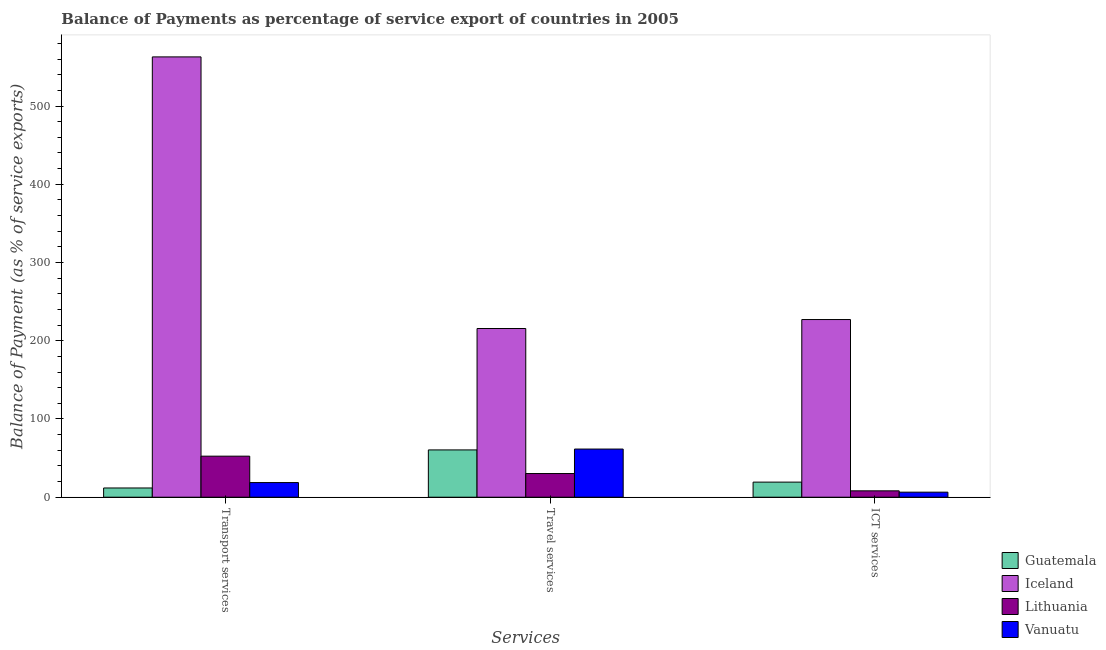How many different coloured bars are there?
Your answer should be compact. 4. How many groups of bars are there?
Provide a succinct answer. 3. Are the number of bars per tick equal to the number of legend labels?
Give a very brief answer. Yes. How many bars are there on the 3rd tick from the left?
Keep it short and to the point. 4. How many bars are there on the 1st tick from the right?
Give a very brief answer. 4. What is the label of the 1st group of bars from the left?
Offer a terse response. Transport services. What is the balance of payment of ict services in Guatemala?
Keep it short and to the point. 19.31. Across all countries, what is the maximum balance of payment of ict services?
Provide a short and direct response. 227.09. Across all countries, what is the minimum balance of payment of ict services?
Ensure brevity in your answer.  6.47. In which country was the balance of payment of transport services minimum?
Give a very brief answer. Guatemala. What is the total balance of payment of transport services in the graph?
Provide a succinct answer. 645.81. What is the difference between the balance of payment of transport services in Vanuatu and that in Guatemala?
Your answer should be compact. 6.9. What is the difference between the balance of payment of ict services in Iceland and the balance of payment of travel services in Guatemala?
Offer a terse response. 166.63. What is the average balance of payment of transport services per country?
Your response must be concise. 161.45. What is the difference between the balance of payment of transport services and balance of payment of ict services in Vanuatu?
Your answer should be compact. 12.25. In how many countries, is the balance of payment of ict services greater than 520 %?
Ensure brevity in your answer.  0. What is the ratio of the balance of payment of ict services in Guatemala to that in Lithuania?
Provide a short and direct response. 2.37. Is the balance of payment of travel services in Lithuania less than that in Guatemala?
Keep it short and to the point. Yes. What is the difference between the highest and the second highest balance of payment of ict services?
Offer a terse response. 207.78. What is the difference between the highest and the lowest balance of payment of travel services?
Provide a short and direct response. 185.37. Is the sum of the balance of payment of transport services in Iceland and Vanuatu greater than the maximum balance of payment of ict services across all countries?
Offer a very short reply. Yes. What does the 1st bar from the left in ICT services represents?
Provide a short and direct response. Guatemala. What does the 3rd bar from the right in Transport services represents?
Give a very brief answer. Iceland. Is it the case that in every country, the sum of the balance of payment of transport services and balance of payment of travel services is greater than the balance of payment of ict services?
Offer a terse response. Yes. Are all the bars in the graph horizontal?
Your response must be concise. No. How many countries are there in the graph?
Your response must be concise. 4. What is the difference between two consecutive major ticks on the Y-axis?
Your response must be concise. 100. How many legend labels are there?
Offer a very short reply. 4. What is the title of the graph?
Ensure brevity in your answer.  Balance of Payments as percentage of service export of countries in 2005. What is the label or title of the X-axis?
Give a very brief answer. Services. What is the label or title of the Y-axis?
Provide a short and direct response. Balance of Payment (as % of service exports). What is the Balance of Payment (as % of service exports) in Guatemala in Transport services?
Provide a succinct answer. 11.81. What is the Balance of Payment (as % of service exports) of Iceland in Transport services?
Make the answer very short. 562.81. What is the Balance of Payment (as % of service exports) of Lithuania in Transport services?
Keep it short and to the point. 52.47. What is the Balance of Payment (as % of service exports) of Vanuatu in Transport services?
Your answer should be compact. 18.72. What is the Balance of Payment (as % of service exports) in Guatemala in Travel services?
Your answer should be very brief. 60.46. What is the Balance of Payment (as % of service exports) of Iceland in Travel services?
Give a very brief answer. 215.64. What is the Balance of Payment (as % of service exports) in Lithuania in Travel services?
Offer a terse response. 30.28. What is the Balance of Payment (as % of service exports) of Vanuatu in Travel services?
Make the answer very short. 61.55. What is the Balance of Payment (as % of service exports) of Guatemala in ICT services?
Provide a succinct answer. 19.31. What is the Balance of Payment (as % of service exports) of Iceland in ICT services?
Give a very brief answer. 227.09. What is the Balance of Payment (as % of service exports) in Lithuania in ICT services?
Give a very brief answer. 8.16. What is the Balance of Payment (as % of service exports) in Vanuatu in ICT services?
Ensure brevity in your answer.  6.47. Across all Services, what is the maximum Balance of Payment (as % of service exports) of Guatemala?
Ensure brevity in your answer.  60.46. Across all Services, what is the maximum Balance of Payment (as % of service exports) in Iceland?
Give a very brief answer. 562.81. Across all Services, what is the maximum Balance of Payment (as % of service exports) of Lithuania?
Provide a succinct answer. 52.47. Across all Services, what is the maximum Balance of Payment (as % of service exports) in Vanuatu?
Ensure brevity in your answer.  61.55. Across all Services, what is the minimum Balance of Payment (as % of service exports) in Guatemala?
Provide a short and direct response. 11.81. Across all Services, what is the minimum Balance of Payment (as % of service exports) in Iceland?
Offer a very short reply. 215.64. Across all Services, what is the minimum Balance of Payment (as % of service exports) of Lithuania?
Your answer should be compact. 8.16. Across all Services, what is the minimum Balance of Payment (as % of service exports) of Vanuatu?
Keep it short and to the point. 6.47. What is the total Balance of Payment (as % of service exports) of Guatemala in the graph?
Provide a short and direct response. 91.58. What is the total Balance of Payment (as % of service exports) of Iceland in the graph?
Ensure brevity in your answer.  1005.54. What is the total Balance of Payment (as % of service exports) in Lithuania in the graph?
Offer a terse response. 90.9. What is the total Balance of Payment (as % of service exports) of Vanuatu in the graph?
Keep it short and to the point. 86.74. What is the difference between the Balance of Payment (as % of service exports) in Guatemala in Transport services and that in Travel services?
Ensure brevity in your answer.  -48.65. What is the difference between the Balance of Payment (as % of service exports) of Iceland in Transport services and that in Travel services?
Your answer should be very brief. 347.16. What is the difference between the Balance of Payment (as % of service exports) in Lithuania in Transport services and that in Travel services?
Offer a very short reply. 22.2. What is the difference between the Balance of Payment (as % of service exports) in Vanuatu in Transport services and that in Travel services?
Keep it short and to the point. -42.84. What is the difference between the Balance of Payment (as % of service exports) of Guatemala in Transport services and that in ICT services?
Provide a short and direct response. -7.49. What is the difference between the Balance of Payment (as % of service exports) of Iceland in Transport services and that in ICT services?
Give a very brief answer. 335.71. What is the difference between the Balance of Payment (as % of service exports) of Lithuania in Transport services and that in ICT services?
Provide a succinct answer. 44.32. What is the difference between the Balance of Payment (as % of service exports) of Vanuatu in Transport services and that in ICT services?
Make the answer very short. 12.25. What is the difference between the Balance of Payment (as % of service exports) in Guatemala in Travel services and that in ICT services?
Your answer should be compact. 41.15. What is the difference between the Balance of Payment (as % of service exports) of Iceland in Travel services and that in ICT services?
Make the answer very short. -11.45. What is the difference between the Balance of Payment (as % of service exports) of Lithuania in Travel services and that in ICT services?
Offer a very short reply. 22.12. What is the difference between the Balance of Payment (as % of service exports) of Vanuatu in Travel services and that in ICT services?
Your response must be concise. 55.09. What is the difference between the Balance of Payment (as % of service exports) in Guatemala in Transport services and the Balance of Payment (as % of service exports) in Iceland in Travel services?
Keep it short and to the point. -203.83. What is the difference between the Balance of Payment (as % of service exports) of Guatemala in Transport services and the Balance of Payment (as % of service exports) of Lithuania in Travel services?
Your answer should be very brief. -18.46. What is the difference between the Balance of Payment (as % of service exports) of Guatemala in Transport services and the Balance of Payment (as % of service exports) of Vanuatu in Travel services?
Your answer should be very brief. -49.74. What is the difference between the Balance of Payment (as % of service exports) of Iceland in Transport services and the Balance of Payment (as % of service exports) of Lithuania in Travel services?
Give a very brief answer. 532.53. What is the difference between the Balance of Payment (as % of service exports) in Iceland in Transport services and the Balance of Payment (as % of service exports) in Vanuatu in Travel services?
Your answer should be compact. 501.25. What is the difference between the Balance of Payment (as % of service exports) in Lithuania in Transport services and the Balance of Payment (as % of service exports) in Vanuatu in Travel services?
Offer a terse response. -9.08. What is the difference between the Balance of Payment (as % of service exports) of Guatemala in Transport services and the Balance of Payment (as % of service exports) of Iceland in ICT services?
Offer a very short reply. -215.28. What is the difference between the Balance of Payment (as % of service exports) in Guatemala in Transport services and the Balance of Payment (as % of service exports) in Lithuania in ICT services?
Offer a terse response. 3.66. What is the difference between the Balance of Payment (as % of service exports) of Guatemala in Transport services and the Balance of Payment (as % of service exports) of Vanuatu in ICT services?
Make the answer very short. 5.35. What is the difference between the Balance of Payment (as % of service exports) in Iceland in Transport services and the Balance of Payment (as % of service exports) in Lithuania in ICT services?
Your response must be concise. 554.65. What is the difference between the Balance of Payment (as % of service exports) in Iceland in Transport services and the Balance of Payment (as % of service exports) in Vanuatu in ICT services?
Your response must be concise. 556.34. What is the difference between the Balance of Payment (as % of service exports) of Lithuania in Transport services and the Balance of Payment (as % of service exports) of Vanuatu in ICT services?
Provide a succinct answer. 46. What is the difference between the Balance of Payment (as % of service exports) in Guatemala in Travel services and the Balance of Payment (as % of service exports) in Iceland in ICT services?
Offer a terse response. -166.63. What is the difference between the Balance of Payment (as % of service exports) of Guatemala in Travel services and the Balance of Payment (as % of service exports) of Lithuania in ICT services?
Give a very brief answer. 52.31. What is the difference between the Balance of Payment (as % of service exports) in Guatemala in Travel services and the Balance of Payment (as % of service exports) in Vanuatu in ICT services?
Make the answer very short. 53.99. What is the difference between the Balance of Payment (as % of service exports) of Iceland in Travel services and the Balance of Payment (as % of service exports) of Lithuania in ICT services?
Make the answer very short. 207.49. What is the difference between the Balance of Payment (as % of service exports) of Iceland in Travel services and the Balance of Payment (as % of service exports) of Vanuatu in ICT services?
Give a very brief answer. 209.18. What is the difference between the Balance of Payment (as % of service exports) of Lithuania in Travel services and the Balance of Payment (as % of service exports) of Vanuatu in ICT services?
Keep it short and to the point. 23.81. What is the average Balance of Payment (as % of service exports) of Guatemala per Services?
Offer a terse response. 30.53. What is the average Balance of Payment (as % of service exports) of Iceland per Services?
Your answer should be very brief. 335.18. What is the average Balance of Payment (as % of service exports) in Lithuania per Services?
Ensure brevity in your answer.  30.3. What is the average Balance of Payment (as % of service exports) in Vanuatu per Services?
Offer a terse response. 28.91. What is the difference between the Balance of Payment (as % of service exports) of Guatemala and Balance of Payment (as % of service exports) of Iceland in Transport services?
Give a very brief answer. -550.99. What is the difference between the Balance of Payment (as % of service exports) of Guatemala and Balance of Payment (as % of service exports) of Lithuania in Transport services?
Ensure brevity in your answer.  -40.66. What is the difference between the Balance of Payment (as % of service exports) of Guatemala and Balance of Payment (as % of service exports) of Vanuatu in Transport services?
Provide a succinct answer. -6.9. What is the difference between the Balance of Payment (as % of service exports) in Iceland and Balance of Payment (as % of service exports) in Lithuania in Transport services?
Your answer should be compact. 510.34. What is the difference between the Balance of Payment (as % of service exports) of Iceland and Balance of Payment (as % of service exports) of Vanuatu in Transport services?
Ensure brevity in your answer.  544.09. What is the difference between the Balance of Payment (as % of service exports) of Lithuania and Balance of Payment (as % of service exports) of Vanuatu in Transport services?
Ensure brevity in your answer.  33.75. What is the difference between the Balance of Payment (as % of service exports) of Guatemala and Balance of Payment (as % of service exports) of Iceland in Travel services?
Give a very brief answer. -155.18. What is the difference between the Balance of Payment (as % of service exports) of Guatemala and Balance of Payment (as % of service exports) of Lithuania in Travel services?
Give a very brief answer. 30.19. What is the difference between the Balance of Payment (as % of service exports) in Guatemala and Balance of Payment (as % of service exports) in Vanuatu in Travel services?
Your answer should be very brief. -1.09. What is the difference between the Balance of Payment (as % of service exports) in Iceland and Balance of Payment (as % of service exports) in Lithuania in Travel services?
Ensure brevity in your answer.  185.37. What is the difference between the Balance of Payment (as % of service exports) of Iceland and Balance of Payment (as % of service exports) of Vanuatu in Travel services?
Keep it short and to the point. 154.09. What is the difference between the Balance of Payment (as % of service exports) of Lithuania and Balance of Payment (as % of service exports) of Vanuatu in Travel services?
Provide a succinct answer. -31.28. What is the difference between the Balance of Payment (as % of service exports) of Guatemala and Balance of Payment (as % of service exports) of Iceland in ICT services?
Offer a terse response. -207.78. What is the difference between the Balance of Payment (as % of service exports) in Guatemala and Balance of Payment (as % of service exports) in Lithuania in ICT services?
Provide a short and direct response. 11.15. What is the difference between the Balance of Payment (as % of service exports) in Guatemala and Balance of Payment (as % of service exports) in Vanuatu in ICT services?
Offer a terse response. 12.84. What is the difference between the Balance of Payment (as % of service exports) in Iceland and Balance of Payment (as % of service exports) in Lithuania in ICT services?
Keep it short and to the point. 218.94. What is the difference between the Balance of Payment (as % of service exports) of Iceland and Balance of Payment (as % of service exports) of Vanuatu in ICT services?
Your answer should be compact. 220.63. What is the difference between the Balance of Payment (as % of service exports) in Lithuania and Balance of Payment (as % of service exports) in Vanuatu in ICT services?
Provide a succinct answer. 1.69. What is the ratio of the Balance of Payment (as % of service exports) of Guatemala in Transport services to that in Travel services?
Provide a short and direct response. 0.2. What is the ratio of the Balance of Payment (as % of service exports) of Iceland in Transport services to that in Travel services?
Offer a terse response. 2.61. What is the ratio of the Balance of Payment (as % of service exports) of Lithuania in Transport services to that in Travel services?
Your response must be concise. 1.73. What is the ratio of the Balance of Payment (as % of service exports) of Vanuatu in Transport services to that in Travel services?
Your response must be concise. 0.3. What is the ratio of the Balance of Payment (as % of service exports) of Guatemala in Transport services to that in ICT services?
Give a very brief answer. 0.61. What is the ratio of the Balance of Payment (as % of service exports) in Iceland in Transport services to that in ICT services?
Give a very brief answer. 2.48. What is the ratio of the Balance of Payment (as % of service exports) in Lithuania in Transport services to that in ICT services?
Your response must be concise. 6.43. What is the ratio of the Balance of Payment (as % of service exports) of Vanuatu in Transport services to that in ICT services?
Offer a very short reply. 2.89. What is the ratio of the Balance of Payment (as % of service exports) of Guatemala in Travel services to that in ICT services?
Provide a succinct answer. 3.13. What is the ratio of the Balance of Payment (as % of service exports) in Iceland in Travel services to that in ICT services?
Your answer should be compact. 0.95. What is the ratio of the Balance of Payment (as % of service exports) of Lithuania in Travel services to that in ICT services?
Give a very brief answer. 3.71. What is the ratio of the Balance of Payment (as % of service exports) of Vanuatu in Travel services to that in ICT services?
Offer a terse response. 9.52. What is the difference between the highest and the second highest Balance of Payment (as % of service exports) in Guatemala?
Provide a short and direct response. 41.15. What is the difference between the highest and the second highest Balance of Payment (as % of service exports) of Iceland?
Make the answer very short. 335.71. What is the difference between the highest and the second highest Balance of Payment (as % of service exports) in Lithuania?
Your answer should be very brief. 22.2. What is the difference between the highest and the second highest Balance of Payment (as % of service exports) of Vanuatu?
Your response must be concise. 42.84. What is the difference between the highest and the lowest Balance of Payment (as % of service exports) in Guatemala?
Keep it short and to the point. 48.65. What is the difference between the highest and the lowest Balance of Payment (as % of service exports) of Iceland?
Your answer should be very brief. 347.16. What is the difference between the highest and the lowest Balance of Payment (as % of service exports) in Lithuania?
Your answer should be very brief. 44.32. What is the difference between the highest and the lowest Balance of Payment (as % of service exports) of Vanuatu?
Your answer should be very brief. 55.09. 